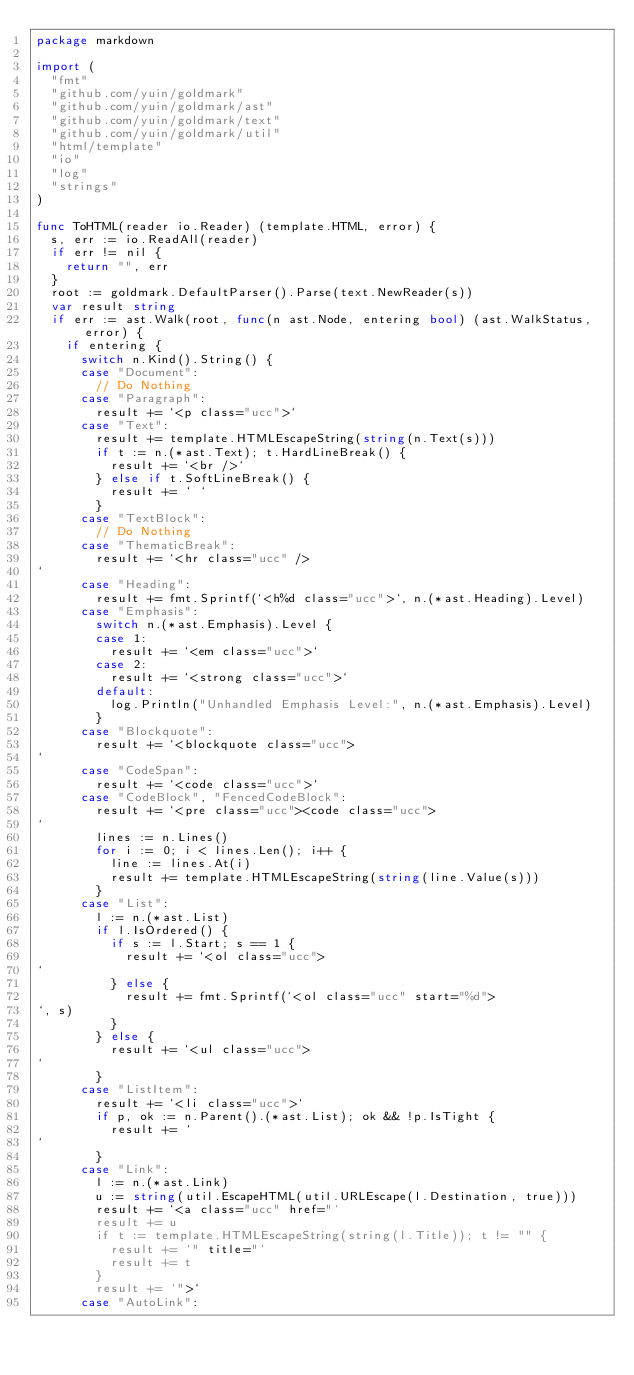<code> <loc_0><loc_0><loc_500><loc_500><_Go_>package markdown

import (
	"fmt"
	"github.com/yuin/goldmark"
	"github.com/yuin/goldmark/ast"
	"github.com/yuin/goldmark/text"
	"github.com/yuin/goldmark/util"
	"html/template"
	"io"
	"log"
	"strings"
)

func ToHTML(reader io.Reader) (template.HTML, error) {
	s, err := io.ReadAll(reader)
	if err != nil {
		return "", err
	}
	root := goldmark.DefaultParser().Parse(text.NewReader(s))
	var result string
	if err := ast.Walk(root, func(n ast.Node, entering bool) (ast.WalkStatus, error) {
		if entering {
			switch n.Kind().String() {
			case "Document":
				// Do Nothing
			case "Paragraph":
				result += `<p class="ucc">`
			case "Text":
				result += template.HTMLEscapeString(string(n.Text(s)))
				if t := n.(*ast.Text); t.HardLineBreak() {
					result += `<br />`
				} else if t.SoftLineBreak() {
					result += ` `
				}
			case "TextBlock":
				// Do Nothing
			case "ThematicBreak":
				result += `<hr class="ucc" />
`
			case "Heading":
				result += fmt.Sprintf(`<h%d class="ucc">`, n.(*ast.Heading).Level)
			case "Emphasis":
				switch n.(*ast.Emphasis).Level {
				case 1:
					result += `<em class="ucc">`
				case 2:
					result += `<strong class="ucc">`
				default:
					log.Println("Unhandled Emphasis Level:", n.(*ast.Emphasis).Level)
				}
			case "Blockquote":
				result += `<blockquote class="ucc">
`
			case "CodeSpan":
				result += `<code class="ucc">`
			case "CodeBlock", "FencedCodeBlock":
				result += `<pre class="ucc"><code class="ucc">
`
				lines := n.Lines()
				for i := 0; i < lines.Len(); i++ {
					line := lines.At(i)
					result += template.HTMLEscapeString(string(line.Value(s)))
				}
			case "List":
				l := n.(*ast.List)
				if l.IsOrdered() {
					if s := l.Start; s == 1 {
						result += `<ol class="ucc">
`
					} else {
						result += fmt.Sprintf(`<ol class="ucc" start="%d">
`, s)
					}
				} else {
					result += `<ul class="ucc">
`
				}
			case "ListItem":
				result += `<li class="ucc">`
				if p, ok := n.Parent().(*ast.List); ok && !p.IsTight {
					result += `
`
				}
			case "Link":
				l := n.(*ast.Link)
				u := string(util.EscapeHTML(util.URLEscape(l.Destination, true)))
				result += `<a class="ucc" href="`
				result += u
				if t := template.HTMLEscapeString(string(l.Title)); t != "" {
					result += `" title="`
					result += t
				}
				result += `">`
			case "AutoLink":</code> 